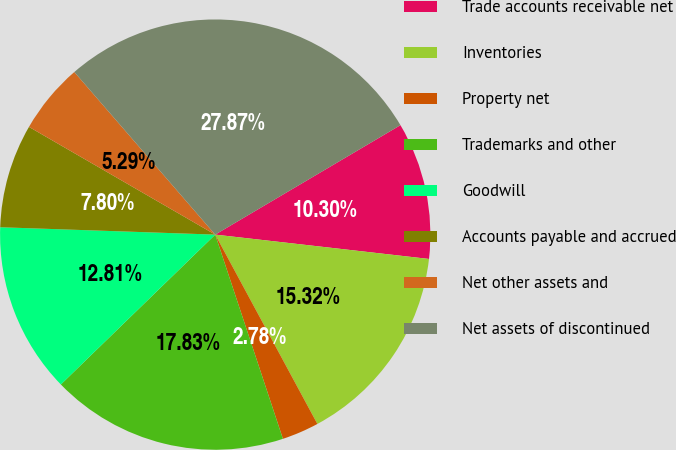Convert chart to OTSL. <chart><loc_0><loc_0><loc_500><loc_500><pie_chart><fcel>Trade accounts receivable net<fcel>Inventories<fcel>Property net<fcel>Trademarks and other<fcel>Goodwill<fcel>Accounts payable and accrued<fcel>Net other assets and<fcel>Net assets of discontinued<nl><fcel>10.3%<fcel>15.32%<fcel>2.78%<fcel>17.83%<fcel>12.81%<fcel>7.8%<fcel>5.29%<fcel>27.87%<nl></chart> 